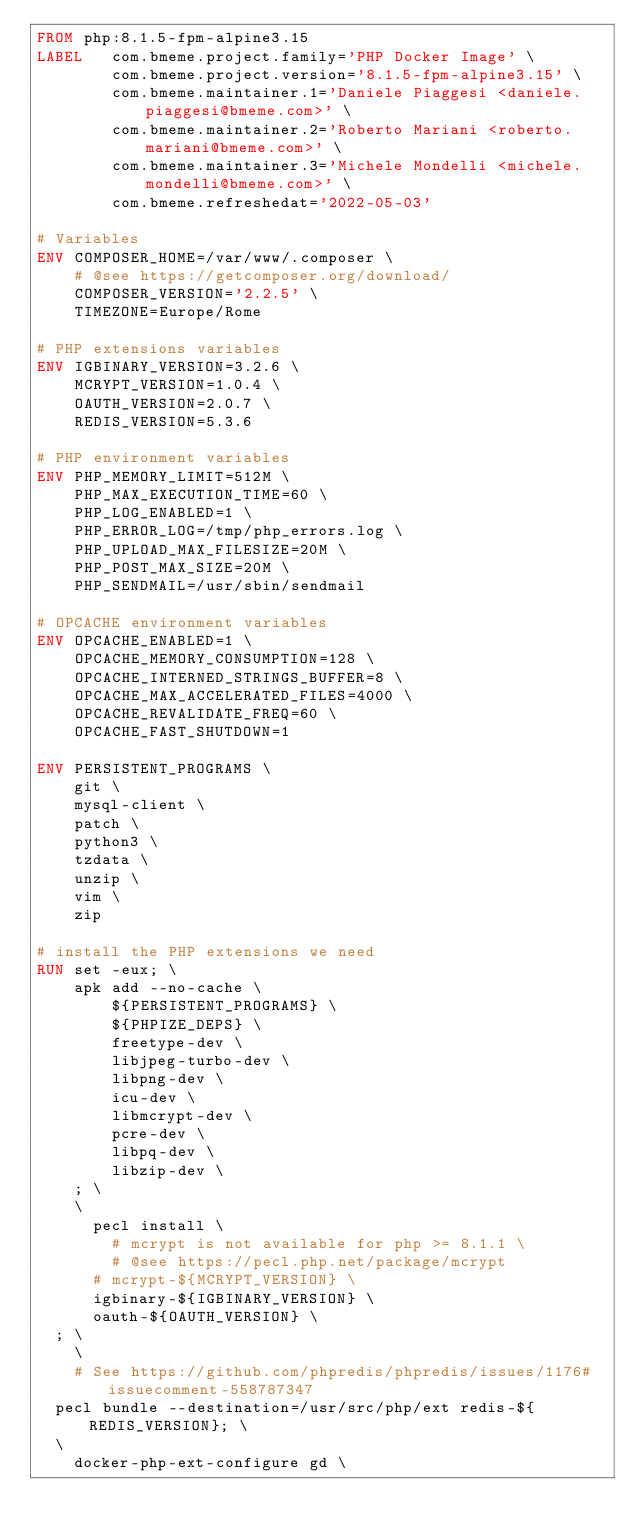Convert code to text. <code><loc_0><loc_0><loc_500><loc_500><_Dockerfile_>FROM php:8.1.5-fpm-alpine3.15
LABEL   com.bmeme.project.family='PHP Docker Image' \
        com.bmeme.project.version='8.1.5-fpm-alpine3.15' \
        com.bmeme.maintainer.1='Daniele Piaggesi <daniele.piaggesi@bmeme.com>' \
        com.bmeme.maintainer.2='Roberto Mariani <roberto.mariani@bmeme.com>' \
        com.bmeme.maintainer.3='Michele Mondelli <michele.mondelli@bmeme.com>' \
        com.bmeme.refreshedat='2022-05-03'

# Variables
ENV COMPOSER_HOME=/var/www/.composer \
    # @see https://getcomposer.org/download/
    COMPOSER_VERSION='2.2.5' \
    TIMEZONE=Europe/Rome

# PHP extensions variables
ENV IGBINARY_VERSION=3.2.6 \
    MCRYPT_VERSION=1.0.4 \
    OAUTH_VERSION=2.0.7 \
    REDIS_VERSION=5.3.6

# PHP environment variables
ENV PHP_MEMORY_LIMIT=512M \
    PHP_MAX_EXECUTION_TIME=60 \
    PHP_LOG_ENABLED=1 \
    PHP_ERROR_LOG=/tmp/php_errors.log \
    PHP_UPLOAD_MAX_FILESIZE=20M \
    PHP_POST_MAX_SIZE=20M \
    PHP_SENDMAIL=/usr/sbin/sendmail

# OPCACHE environment variables
ENV OPCACHE_ENABLED=1 \
    OPCACHE_MEMORY_CONSUMPTION=128 \
    OPCACHE_INTERNED_STRINGS_BUFFER=8 \
    OPCACHE_MAX_ACCELERATED_FILES=4000 \
    OPCACHE_REVALIDATE_FREQ=60 \
    OPCACHE_FAST_SHUTDOWN=1

ENV PERSISTENT_PROGRAMS \
    git \
    mysql-client \
    patch \
    python3 \
    tzdata \
    unzip \
    vim \
    zip

# install the PHP extensions we need
RUN set -eux; \
    apk add --no-cache \
        ${PERSISTENT_PROGRAMS} \
        ${PHPIZE_DEPS} \
        freetype-dev \
        libjpeg-turbo-dev \
        libpng-dev \
        icu-dev \
        libmcrypt-dev \
        pcre-dev \
        libpq-dev \
        libzip-dev \
    ; \    
    \
    	pecl install \
        # mcrypt is not available for php >= 8.1.1 \
        # @see https://pecl.php.net/package/mcrypt
	    # mcrypt-${MCRYPT_VERSION} \
	    igbinary-${IGBINARY_VERSION} \
	    oauth-${OAUTH_VERSION} \
	; \
    \
    # See https://github.com/phpredis/phpredis/issues/1176#issuecomment-558787347
	pecl bundle --destination=/usr/src/php/ext redis-${REDIS_VERSION}; \
	\
    docker-php-ext-configure gd \</code> 